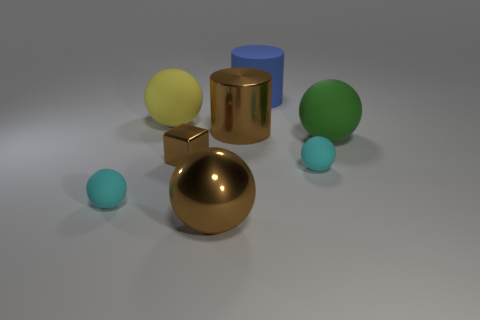There is a big object in front of the tiny cyan ball that is to the left of the yellow matte ball; are there any large blue matte cylinders that are behind it?
Make the answer very short. Yes. Are there any objects on the left side of the large matte cylinder?
Provide a short and direct response. Yes. How many large cylinders are the same color as the metal block?
Your response must be concise. 1. What size is the brown block that is made of the same material as the brown ball?
Offer a very short reply. Small. There is a cyan ball to the left of the small thing that is right of the big thing that is in front of the green rubber thing; what is its size?
Provide a succinct answer. Small. There is a cyan object that is on the right side of the brown shiny cube; what size is it?
Your response must be concise. Small. How many green things are either matte things or small rubber balls?
Ensure brevity in your answer.  1. Is there a blue shiny object that has the same size as the brown shiny block?
Offer a terse response. No. There is a brown thing that is the same size as the brown ball; what material is it?
Your response must be concise. Metal. Is the size of the cyan sphere left of the tiny cube the same as the cyan rubber sphere that is to the right of the tiny shiny thing?
Your answer should be very brief. Yes. 